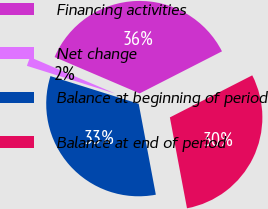<chart> <loc_0><loc_0><loc_500><loc_500><pie_chart><fcel>Financing activities<fcel>Net change<fcel>Balance at beginning of period<fcel>Balance at end of period<nl><fcel>36.05%<fcel>1.59%<fcel>32.8%<fcel>29.55%<nl></chart> 